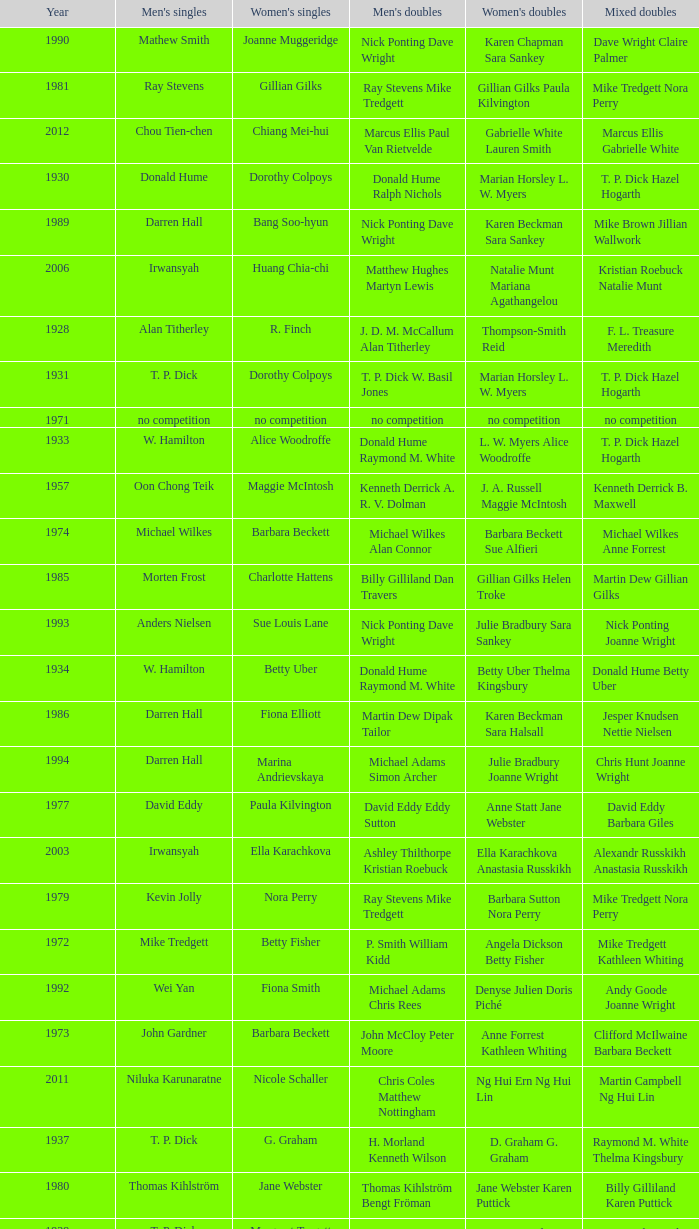Who won the Men's singles in the year that Ian Maconachie Marian Horsley won the Mixed doubles? Raymond M. White. 